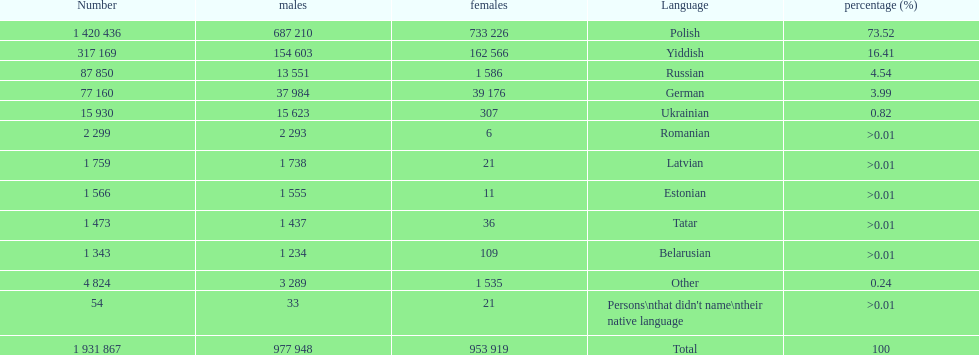Which language had the most number of people speaking it. Polish. 